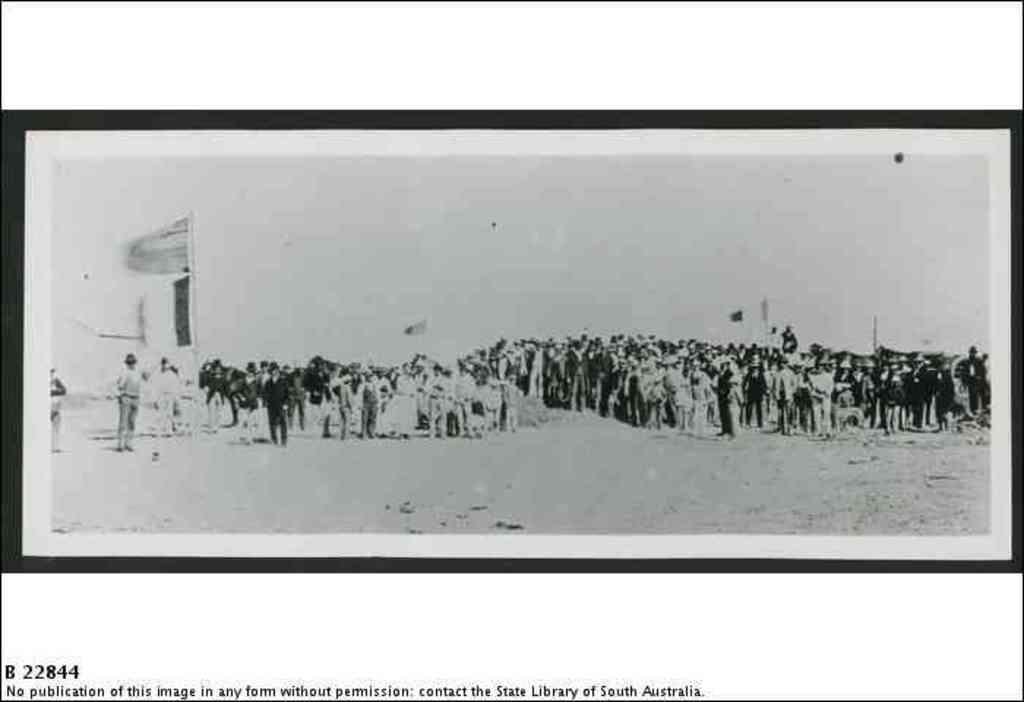<image>
Describe the image concisely. an picture with the numbers 22844 on it 